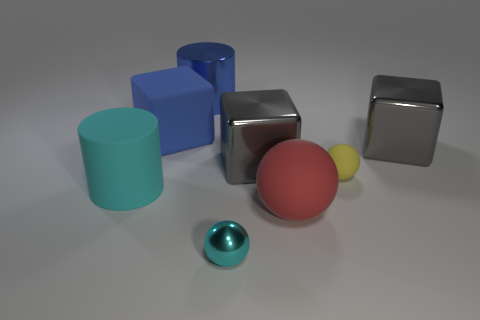Is the large ball the same color as the metallic cylinder?
Your answer should be compact. No. The tiny sphere that is to the left of the tiny sphere that is behind the small sphere in front of the cyan cylinder is what color?
Provide a succinct answer. Cyan. What number of gray metal objects are in front of the big cylinder that is on the left side of the cylinder that is behind the large cyan object?
Keep it short and to the point. 0. Is there anything else of the same color as the tiny shiny sphere?
Offer a terse response. Yes. Is the size of the cylinder in front of the blue metal thing the same as the small matte thing?
Offer a terse response. No. What number of tiny cyan objects are to the right of the metal object on the left side of the small cyan thing?
Keep it short and to the point. 1. There is a big cylinder in front of the big cylinder that is behind the big cyan object; are there any gray metal things that are in front of it?
Keep it short and to the point. No. What material is the small cyan object that is the same shape as the yellow thing?
Your answer should be compact. Metal. Is there any other thing that is the same material as the tiny cyan thing?
Keep it short and to the point. Yes. Do the blue cube and the ball behind the large rubber ball have the same material?
Your answer should be compact. Yes. 